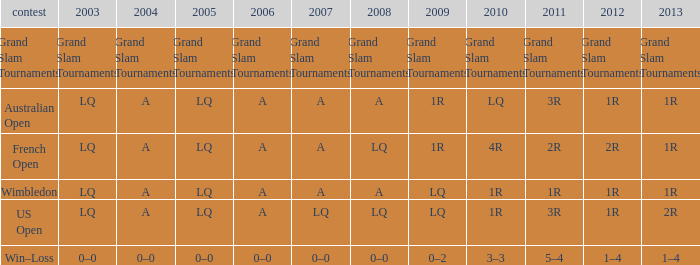Which year has a 2011 of 1r? A. 